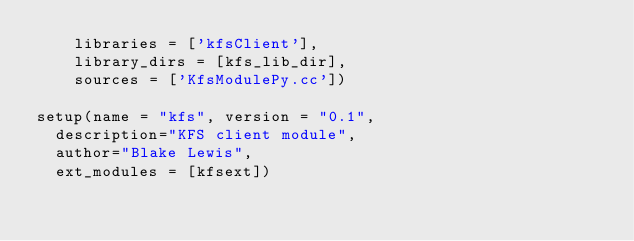<code> <loc_0><loc_0><loc_500><loc_500><_Python_>		libraries = ['kfsClient'],
		library_dirs = [kfs_lib_dir],
		sources = ['KfsModulePy.cc'])

setup(name = "kfs", version = "0.1",
	description="KFS client module",
	author="Blake Lewis",
	ext_modules = [kfsext])
</code> 